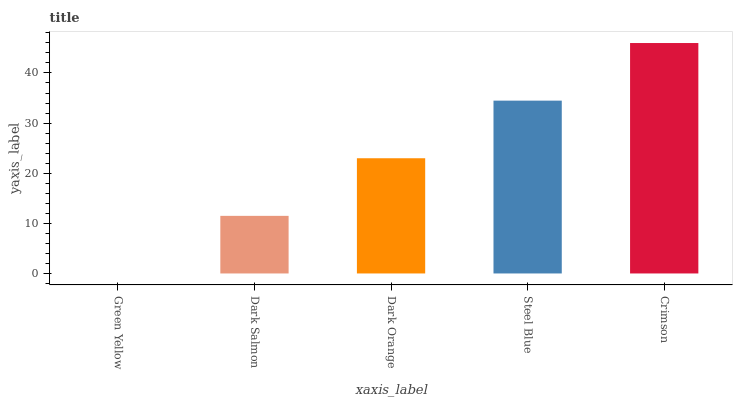Is Green Yellow the minimum?
Answer yes or no. Yes. Is Crimson the maximum?
Answer yes or no. Yes. Is Dark Salmon the minimum?
Answer yes or no. No. Is Dark Salmon the maximum?
Answer yes or no. No. Is Dark Salmon greater than Green Yellow?
Answer yes or no. Yes. Is Green Yellow less than Dark Salmon?
Answer yes or no. Yes. Is Green Yellow greater than Dark Salmon?
Answer yes or no. No. Is Dark Salmon less than Green Yellow?
Answer yes or no. No. Is Dark Orange the high median?
Answer yes or no. Yes. Is Dark Orange the low median?
Answer yes or no. Yes. Is Dark Salmon the high median?
Answer yes or no. No. Is Green Yellow the low median?
Answer yes or no. No. 